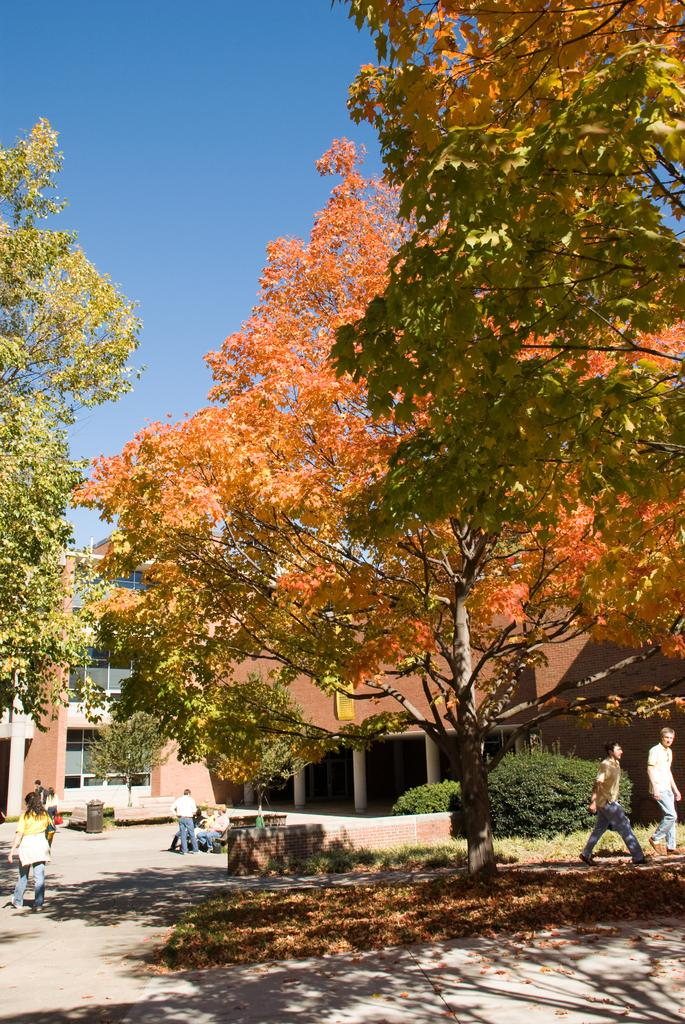What type of structures are present in the image? There are buildings in the image. What other natural elements can be seen in the image? There are trees in the image. Can you describe the people in the image? There is a group of people in the image, with some seated on a bench and others walking. What object might be used for waste disposal in the image? There is a dustbin in the image. What type of oatmeal is being served to the friends in the image? There is no oatmeal or friends present in the image. What type of metal is used to construct the buildings in the image? The provided facts do not specify the type of metal used in the construction of the buildings, if any. 